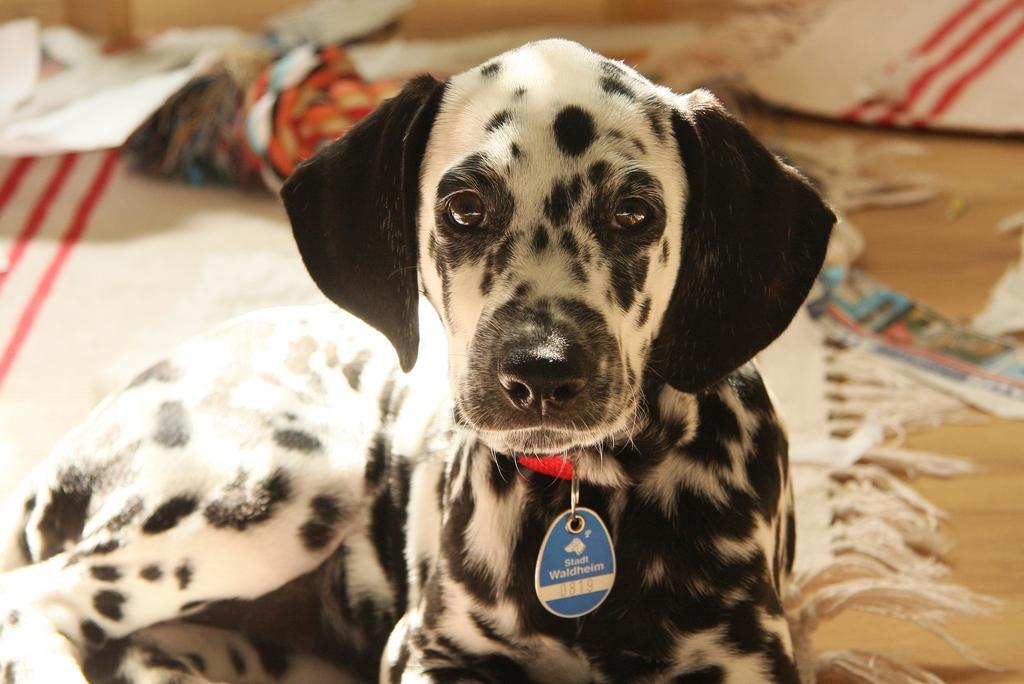How would you summarize this image in a sentence or two? In this image we can see a dog wearing a collar with a tag. In the back there are carpets on the floor. And it is looking blur in the background. 